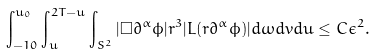<formula> <loc_0><loc_0><loc_500><loc_500>\int _ { - 1 0 } ^ { u _ { 0 } } \int _ { u } ^ { 2 T - u } \int _ { S ^ { 2 } } | \Box \partial ^ { \alpha } \phi | r ^ { 3 } | L ( r \partial ^ { \alpha } \phi ) | d \omega d v d u \leq C \epsilon ^ { 2 } .</formula> 